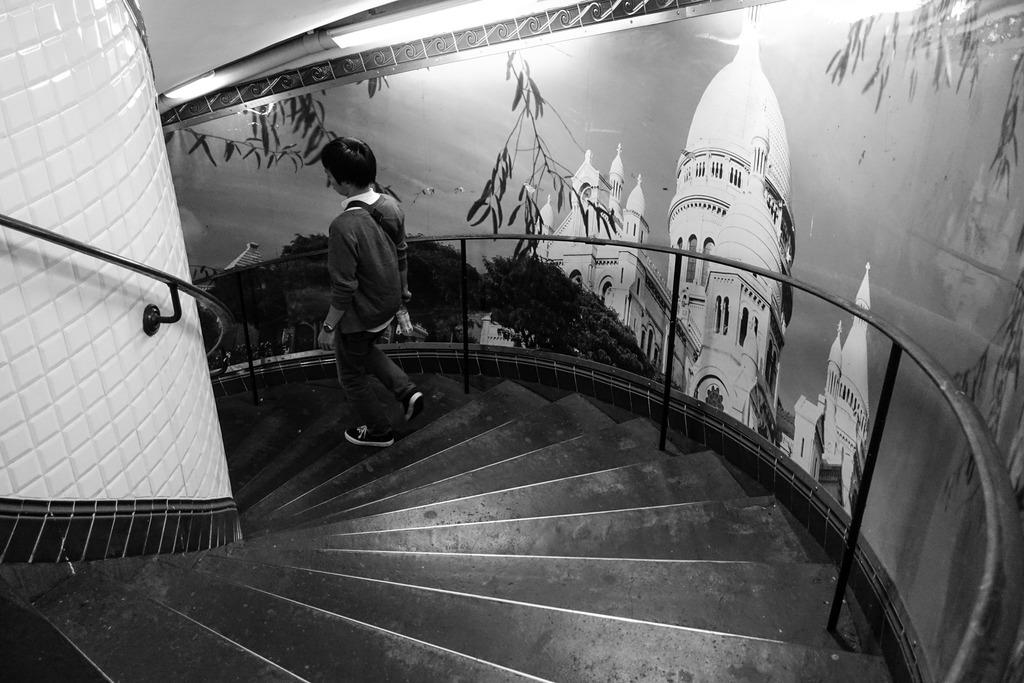What is the person in the image doing? The person is walking on the stairs. What is the person holding while walking on the stairs? The person is holding a white color object. What can be seen on the wall in the image? There is a poster attached to the wall. What is depicted on the poster? The poster contains images of trees and buildings. What disease is the person suffering from in the image? There is no indication of any disease in the image; the person is simply walking on the stairs. 